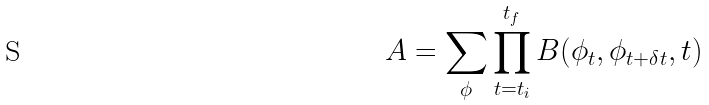<formula> <loc_0><loc_0><loc_500><loc_500>A = \sum _ { \phi } \prod _ { t = t _ { i } } ^ { t _ { f } } B ( \phi _ { t } , \phi _ { t + \delta t } , t )</formula> 